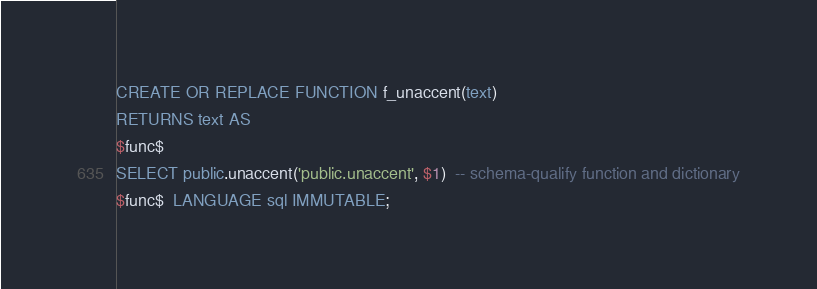<code> <loc_0><loc_0><loc_500><loc_500><_SQL_>CREATE OR REPLACE FUNCTION f_unaccent(text)
RETURNS text AS
$func$
SELECT public.unaccent('public.unaccent', $1)  -- schema-qualify function and dictionary
$func$  LANGUAGE sql IMMUTABLE;
</code> 